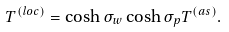Convert formula to latex. <formula><loc_0><loc_0><loc_500><loc_500>T ^ { ( l o c ) } = \cosh \sigma _ { w } \cosh \sigma _ { p } T ^ { ( a s ) } .</formula> 